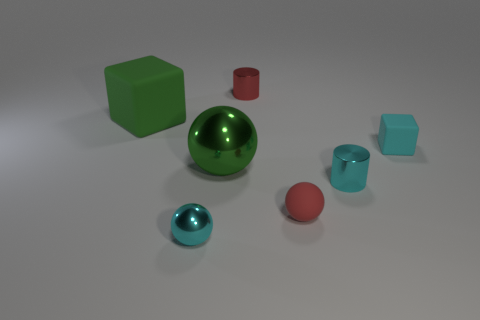Could you infer the textural differences among the objects? Certainly. In the image, the large green sphere and the small red sphere have reflective, shiny surfaces suggesting a metallic texture. The cubes and cylinder appear to have a matte finish, indicating a less reflective, possibly plastic-like texture. 